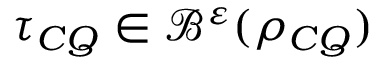Convert formula to latex. <formula><loc_0><loc_0><loc_500><loc_500>\tau _ { C Q } \in \mathcal { B } ^ { \varepsilon } ( \rho _ { C Q } )</formula> 